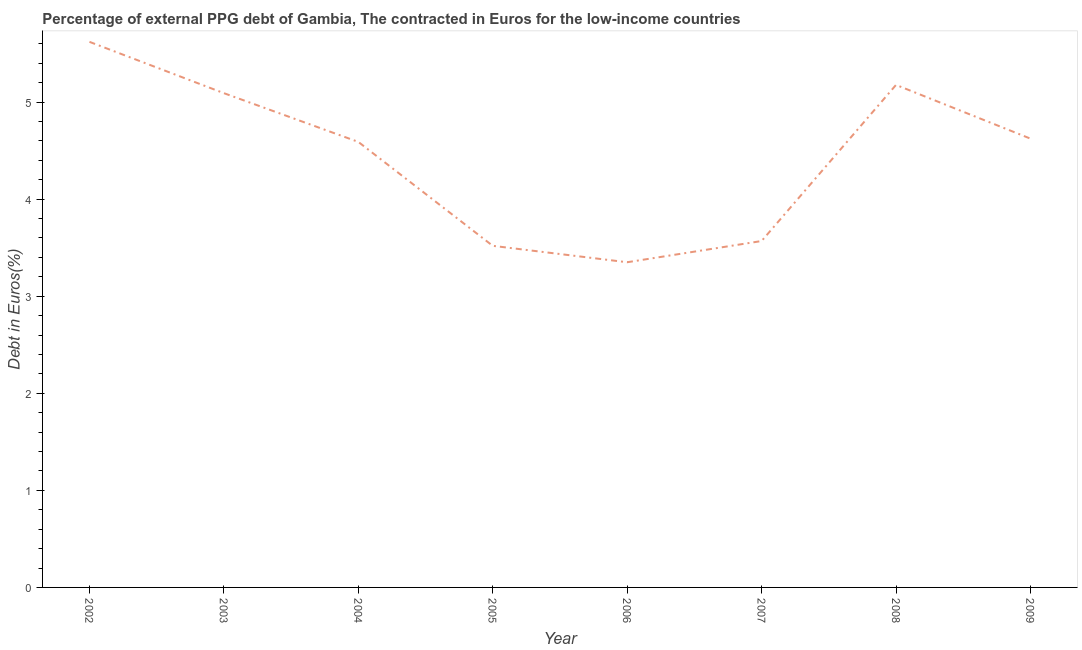What is the currency composition of ppg debt in 2006?
Make the answer very short. 3.35. Across all years, what is the maximum currency composition of ppg debt?
Provide a succinct answer. 5.62. Across all years, what is the minimum currency composition of ppg debt?
Ensure brevity in your answer.  3.35. What is the sum of the currency composition of ppg debt?
Offer a terse response. 35.54. What is the difference between the currency composition of ppg debt in 2004 and 2008?
Make the answer very short. -0.59. What is the average currency composition of ppg debt per year?
Give a very brief answer. 4.44. What is the median currency composition of ppg debt?
Offer a very short reply. 4.61. In how many years, is the currency composition of ppg debt greater than 3.8 %?
Make the answer very short. 5. Do a majority of the years between 2005 and 2007 (inclusive) have currency composition of ppg debt greater than 4.4 %?
Your answer should be very brief. No. What is the ratio of the currency composition of ppg debt in 2003 to that in 2006?
Provide a succinct answer. 1.52. What is the difference between the highest and the second highest currency composition of ppg debt?
Your answer should be compact. 0.44. What is the difference between the highest and the lowest currency composition of ppg debt?
Provide a short and direct response. 2.27. Does the currency composition of ppg debt monotonically increase over the years?
Provide a succinct answer. No. How many years are there in the graph?
Offer a terse response. 8. Does the graph contain grids?
Your answer should be compact. No. What is the title of the graph?
Your answer should be compact. Percentage of external PPG debt of Gambia, The contracted in Euros for the low-income countries. What is the label or title of the Y-axis?
Your answer should be compact. Debt in Euros(%). What is the Debt in Euros(%) in 2002?
Give a very brief answer. 5.62. What is the Debt in Euros(%) of 2003?
Ensure brevity in your answer.  5.09. What is the Debt in Euros(%) in 2004?
Offer a very short reply. 4.59. What is the Debt in Euros(%) of 2005?
Provide a short and direct response. 3.52. What is the Debt in Euros(%) of 2006?
Provide a short and direct response. 3.35. What is the Debt in Euros(%) in 2007?
Your response must be concise. 3.57. What is the Debt in Euros(%) in 2008?
Provide a succinct answer. 5.18. What is the Debt in Euros(%) in 2009?
Provide a succinct answer. 4.62. What is the difference between the Debt in Euros(%) in 2002 and 2003?
Offer a very short reply. 0.53. What is the difference between the Debt in Euros(%) in 2002 and 2004?
Make the answer very short. 1.03. What is the difference between the Debt in Euros(%) in 2002 and 2005?
Keep it short and to the point. 2.1. What is the difference between the Debt in Euros(%) in 2002 and 2006?
Make the answer very short. 2.27. What is the difference between the Debt in Euros(%) in 2002 and 2007?
Give a very brief answer. 2.05. What is the difference between the Debt in Euros(%) in 2002 and 2008?
Provide a succinct answer. 0.44. What is the difference between the Debt in Euros(%) in 2003 and 2004?
Provide a short and direct response. 0.5. What is the difference between the Debt in Euros(%) in 2003 and 2005?
Keep it short and to the point. 1.57. What is the difference between the Debt in Euros(%) in 2003 and 2006?
Ensure brevity in your answer.  1.74. What is the difference between the Debt in Euros(%) in 2003 and 2007?
Your answer should be very brief. 1.52. What is the difference between the Debt in Euros(%) in 2003 and 2008?
Give a very brief answer. -0.09. What is the difference between the Debt in Euros(%) in 2003 and 2009?
Provide a succinct answer. 0.47. What is the difference between the Debt in Euros(%) in 2004 and 2005?
Your answer should be compact. 1.07. What is the difference between the Debt in Euros(%) in 2004 and 2006?
Ensure brevity in your answer.  1.24. What is the difference between the Debt in Euros(%) in 2004 and 2007?
Give a very brief answer. 1.02. What is the difference between the Debt in Euros(%) in 2004 and 2008?
Provide a short and direct response. -0.59. What is the difference between the Debt in Euros(%) in 2004 and 2009?
Your answer should be compact. -0.03. What is the difference between the Debt in Euros(%) in 2005 and 2006?
Offer a very short reply. 0.17. What is the difference between the Debt in Euros(%) in 2005 and 2007?
Ensure brevity in your answer.  -0.05. What is the difference between the Debt in Euros(%) in 2005 and 2008?
Keep it short and to the point. -1.66. What is the difference between the Debt in Euros(%) in 2005 and 2009?
Ensure brevity in your answer.  -1.1. What is the difference between the Debt in Euros(%) in 2006 and 2007?
Provide a succinct answer. -0.22. What is the difference between the Debt in Euros(%) in 2006 and 2008?
Your answer should be compact. -1.83. What is the difference between the Debt in Euros(%) in 2006 and 2009?
Make the answer very short. -1.27. What is the difference between the Debt in Euros(%) in 2007 and 2008?
Provide a succinct answer. -1.61. What is the difference between the Debt in Euros(%) in 2007 and 2009?
Make the answer very short. -1.05. What is the difference between the Debt in Euros(%) in 2008 and 2009?
Provide a succinct answer. 0.55. What is the ratio of the Debt in Euros(%) in 2002 to that in 2003?
Your answer should be compact. 1.1. What is the ratio of the Debt in Euros(%) in 2002 to that in 2004?
Provide a short and direct response. 1.23. What is the ratio of the Debt in Euros(%) in 2002 to that in 2005?
Make the answer very short. 1.6. What is the ratio of the Debt in Euros(%) in 2002 to that in 2006?
Your answer should be very brief. 1.68. What is the ratio of the Debt in Euros(%) in 2002 to that in 2007?
Give a very brief answer. 1.57. What is the ratio of the Debt in Euros(%) in 2002 to that in 2008?
Ensure brevity in your answer.  1.09. What is the ratio of the Debt in Euros(%) in 2002 to that in 2009?
Give a very brief answer. 1.22. What is the ratio of the Debt in Euros(%) in 2003 to that in 2004?
Your response must be concise. 1.11. What is the ratio of the Debt in Euros(%) in 2003 to that in 2005?
Offer a terse response. 1.45. What is the ratio of the Debt in Euros(%) in 2003 to that in 2006?
Provide a short and direct response. 1.52. What is the ratio of the Debt in Euros(%) in 2003 to that in 2007?
Offer a terse response. 1.43. What is the ratio of the Debt in Euros(%) in 2003 to that in 2009?
Give a very brief answer. 1.1. What is the ratio of the Debt in Euros(%) in 2004 to that in 2005?
Your response must be concise. 1.3. What is the ratio of the Debt in Euros(%) in 2004 to that in 2006?
Offer a terse response. 1.37. What is the ratio of the Debt in Euros(%) in 2004 to that in 2007?
Ensure brevity in your answer.  1.29. What is the ratio of the Debt in Euros(%) in 2004 to that in 2008?
Your answer should be very brief. 0.89. What is the ratio of the Debt in Euros(%) in 2005 to that in 2008?
Make the answer very short. 0.68. What is the ratio of the Debt in Euros(%) in 2005 to that in 2009?
Make the answer very short. 0.76. What is the ratio of the Debt in Euros(%) in 2006 to that in 2007?
Your answer should be compact. 0.94. What is the ratio of the Debt in Euros(%) in 2006 to that in 2008?
Offer a terse response. 0.65. What is the ratio of the Debt in Euros(%) in 2006 to that in 2009?
Provide a short and direct response. 0.72. What is the ratio of the Debt in Euros(%) in 2007 to that in 2008?
Your answer should be compact. 0.69. What is the ratio of the Debt in Euros(%) in 2007 to that in 2009?
Provide a succinct answer. 0.77. What is the ratio of the Debt in Euros(%) in 2008 to that in 2009?
Offer a very short reply. 1.12. 